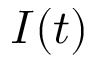<formula> <loc_0><loc_0><loc_500><loc_500>I ( t )</formula> 